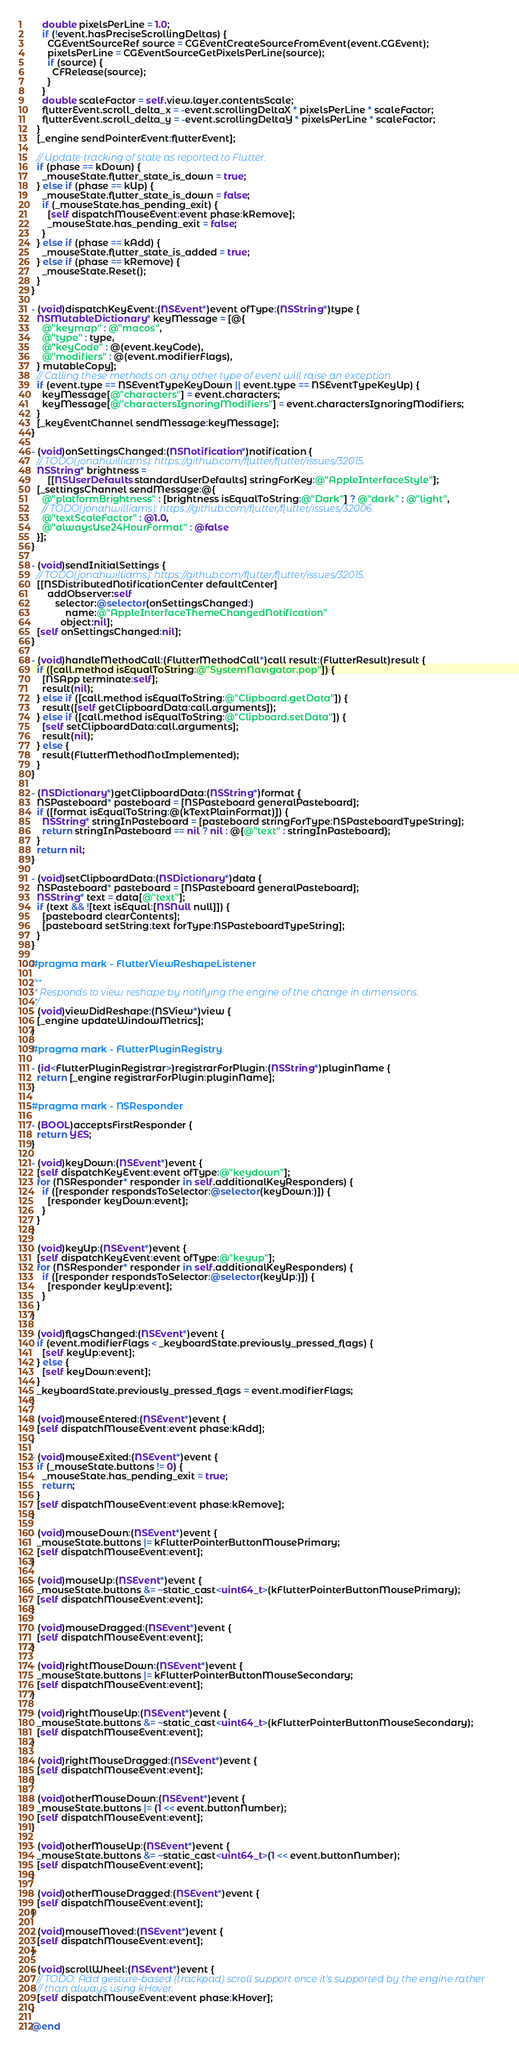<code> <loc_0><loc_0><loc_500><loc_500><_ObjectiveC_>    double pixelsPerLine = 1.0;
    if (!event.hasPreciseScrollingDeltas) {
      CGEventSourceRef source = CGEventCreateSourceFromEvent(event.CGEvent);
      pixelsPerLine = CGEventSourceGetPixelsPerLine(source);
      if (source) {
        CFRelease(source);
      }
    }
    double scaleFactor = self.view.layer.contentsScale;
    flutterEvent.scroll_delta_x = -event.scrollingDeltaX * pixelsPerLine * scaleFactor;
    flutterEvent.scroll_delta_y = -event.scrollingDeltaY * pixelsPerLine * scaleFactor;
  }
  [_engine sendPointerEvent:flutterEvent];

  // Update tracking of state as reported to Flutter.
  if (phase == kDown) {
    _mouseState.flutter_state_is_down = true;
  } else if (phase == kUp) {
    _mouseState.flutter_state_is_down = false;
    if (_mouseState.has_pending_exit) {
      [self dispatchMouseEvent:event phase:kRemove];
      _mouseState.has_pending_exit = false;
    }
  } else if (phase == kAdd) {
    _mouseState.flutter_state_is_added = true;
  } else if (phase == kRemove) {
    _mouseState.Reset();
  }
}

- (void)dispatchKeyEvent:(NSEvent*)event ofType:(NSString*)type {
  NSMutableDictionary* keyMessage = [@{
    @"keymap" : @"macos",
    @"type" : type,
    @"keyCode" : @(event.keyCode),
    @"modifiers" : @(event.modifierFlags),
  } mutableCopy];
  // Calling these methods on any other type of event will raise an exception.
  if (event.type == NSEventTypeKeyDown || event.type == NSEventTypeKeyUp) {
    keyMessage[@"characters"] = event.characters;
    keyMessage[@"charactersIgnoringModifiers"] = event.charactersIgnoringModifiers;
  }
  [_keyEventChannel sendMessage:keyMessage];
}

- (void)onSettingsChanged:(NSNotification*)notification {
  // TODO(jonahwilliams): https://github.com/flutter/flutter/issues/32015.
  NSString* brightness =
      [[NSUserDefaults standardUserDefaults] stringForKey:@"AppleInterfaceStyle"];
  [_settingsChannel sendMessage:@{
    @"platformBrightness" : [brightness isEqualToString:@"Dark"] ? @"dark" : @"light",
    // TODO(jonahwilliams): https://github.com/flutter/flutter/issues/32006.
    @"textScaleFactor" : @1.0,
    @"alwaysUse24HourFormat" : @false
  }];
}

- (void)sendInitialSettings {
  // TODO(jonahwilliams): https://github.com/flutter/flutter/issues/32015.
  [[NSDistributedNotificationCenter defaultCenter]
      addObserver:self
         selector:@selector(onSettingsChanged:)
             name:@"AppleInterfaceThemeChangedNotification"
           object:nil];
  [self onSettingsChanged:nil];
}

- (void)handleMethodCall:(FlutterMethodCall*)call result:(FlutterResult)result {
  if ([call.method isEqualToString:@"SystemNavigator.pop"]) {
    [NSApp terminate:self];
    result(nil);
  } else if ([call.method isEqualToString:@"Clipboard.getData"]) {
    result([self getClipboardData:call.arguments]);
  } else if ([call.method isEqualToString:@"Clipboard.setData"]) {
    [self setClipboardData:call.arguments];
    result(nil);
  } else {
    result(FlutterMethodNotImplemented);
  }
}

- (NSDictionary*)getClipboardData:(NSString*)format {
  NSPasteboard* pasteboard = [NSPasteboard generalPasteboard];
  if ([format isEqualToString:@(kTextPlainFormat)]) {
    NSString* stringInPasteboard = [pasteboard stringForType:NSPasteboardTypeString];
    return stringInPasteboard == nil ? nil : @{@"text" : stringInPasteboard};
  }
  return nil;
}

- (void)setClipboardData:(NSDictionary*)data {
  NSPasteboard* pasteboard = [NSPasteboard generalPasteboard];
  NSString* text = data[@"text"];
  if (text && ![text isEqual:[NSNull null]]) {
    [pasteboard clearContents];
    [pasteboard setString:text forType:NSPasteboardTypeString];
  }
}

#pragma mark - FlutterViewReshapeListener

/**
 * Responds to view reshape by notifying the engine of the change in dimensions.
 */
- (void)viewDidReshape:(NSView*)view {
  [_engine updateWindowMetrics];
}

#pragma mark - FlutterPluginRegistry

- (id<FlutterPluginRegistrar>)registrarForPlugin:(NSString*)pluginName {
  return [_engine registrarForPlugin:pluginName];
}

#pragma mark - NSResponder

- (BOOL)acceptsFirstResponder {
  return YES;
}

- (void)keyDown:(NSEvent*)event {
  [self dispatchKeyEvent:event ofType:@"keydown"];
  for (NSResponder* responder in self.additionalKeyResponders) {
    if ([responder respondsToSelector:@selector(keyDown:)]) {
      [responder keyDown:event];
    }
  }
}

- (void)keyUp:(NSEvent*)event {
  [self dispatchKeyEvent:event ofType:@"keyup"];
  for (NSResponder* responder in self.additionalKeyResponders) {
    if ([responder respondsToSelector:@selector(keyUp:)]) {
      [responder keyUp:event];
    }
  }
}

- (void)flagsChanged:(NSEvent*)event {
  if (event.modifierFlags < _keyboardState.previously_pressed_flags) {
    [self keyUp:event];
  } else {
    [self keyDown:event];
  }
  _keyboardState.previously_pressed_flags = event.modifierFlags;
}

- (void)mouseEntered:(NSEvent*)event {
  [self dispatchMouseEvent:event phase:kAdd];
}

- (void)mouseExited:(NSEvent*)event {
  if (_mouseState.buttons != 0) {
    _mouseState.has_pending_exit = true;
    return;
  }
  [self dispatchMouseEvent:event phase:kRemove];
}

- (void)mouseDown:(NSEvent*)event {
  _mouseState.buttons |= kFlutterPointerButtonMousePrimary;
  [self dispatchMouseEvent:event];
}

- (void)mouseUp:(NSEvent*)event {
  _mouseState.buttons &= ~static_cast<uint64_t>(kFlutterPointerButtonMousePrimary);
  [self dispatchMouseEvent:event];
}

- (void)mouseDragged:(NSEvent*)event {
  [self dispatchMouseEvent:event];
}

- (void)rightMouseDown:(NSEvent*)event {
  _mouseState.buttons |= kFlutterPointerButtonMouseSecondary;
  [self dispatchMouseEvent:event];
}

- (void)rightMouseUp:(NSEvent*)event {
  _mouseState.buttons &= ~static_cast<uint64_t>(kFlutterPointerButtonMouseSecondary);
  [self dispatchMouseEvent:event];
}

- (void)rightMouseDragged:(NSEvent*)event {
  [self dispatchMouseEvent:event];
}

- (void)otherMouseDown:(NSEvent*)event {
  _mouseState.buttons |= (1 << event.buttonNumber);
  [self dispatchMouseEvent:event];
}

- (void)otherMouseUp:(NSEvent*)event {
  _mouseState.buttons &= ~static_cast<uint64_t>(1 << event.buttonNumber);
  [self dispatchMouseEvent:event];
}

- (void)otherMouseDragged:(NSEvent*)event {
  [self dispatchMouseEvent:event];
}

- (void)mouseMoved:(NSEvent*)event {
  [self dispatchMouseEvent:event];
}

- (void)scrollWheel:(NSEvent*)event {
  // TODO: Add gesture-based (trackpad) scroll support once it's supported by the engine rather
  // than always using kHover.
  [self dispatchMouseEvent:event phase:kHover];
}

@end
</code> 